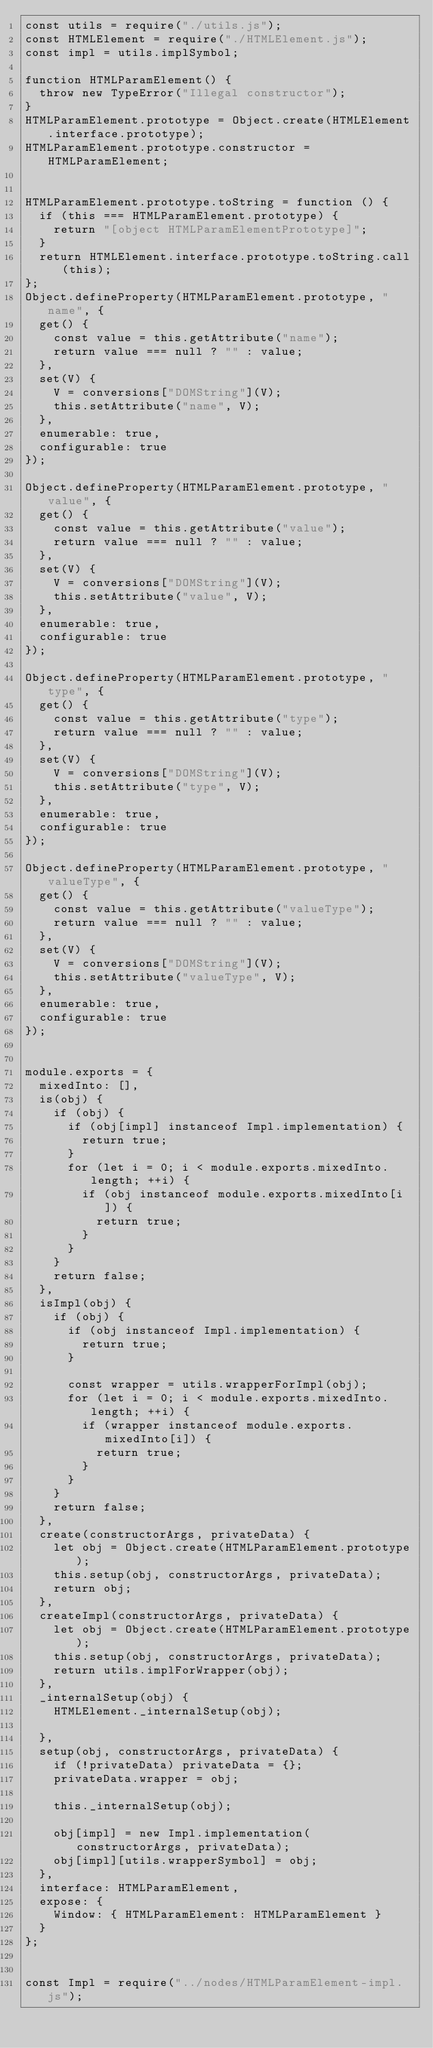Convert code to text. <code><loc_0><loc_0><loc_500><loc_500><_JavaScript_>const utils = require("./utils.js");
const HTMLElement = require("./HTMLElement.js");
const impl = utils.implSymbol;

function HTMLParamElement() {
  throw new TypeError("Illegal constructor");
}
HTMLParamElement.prototype = Object.create(HTMLElement.interface.prototype);
HTMLParamElement.prototype.constructor = HTMLParamElement;


HTMLParamElement.prototype.toString = function () {
  if (this === HTMLParamElement.prototype) {
    return "[object HTMLParamElementPrototype]";
  }
  return HTMLElement.interface.prototype.toString.call(this);
};
Object.defineProperty(HTMLParamElement.prototype, "name", {
  get() {
    const value = this.getAttribute("name");
    return value === null ? "" : value;
  },
  set(V) {
    V = conversions["DOMString"](V);
    this.setAttribute("name", V);
  },
  enumerable: true,
  configurable: true
});

Object.defineProperty(HTMLParamElement.prototype, "value", {
  get() {
    const value = this.getAttribute("value");
    return value === null ? "" : value;
  },
  set(V) {
    V = conversions["DOMString"](V);
    this.setAttribute("value", V);
  },
  enumerable: true,
  configurable: true
});

Object.defineProperty(HTMLParamElement.prototype, "type", {
  get() {
    const value = this.getAttribute("type");
    return value === null ? "" : value;
  },
  set(V) {
    V = conversions["DOMString"](V);
    this.setAttribute("type", V);
  },
  enumerable: true,
  configurable: true
});

Object.defineProperty(HTMLParamElement.prototype, "valueType", {
  get() {
    const value = this.getAttribute("valueType");
    return value === null ? "" : value;
  },
  set(V) {
    V = conversions["DOMString"](V);
    this.setAttribute("valueType", V);
  },
  enumerable: true,
  configurable: true
});


module.exports = {
  mixedInto: [],
  is(obj) {
    if (obj) {
      if (obj[impl] instanceof Impl.implementation) {
        return true;
      }
      for (let i = 0; i < module.exports.mixedInto.length; ++i) {
        if (obj instanceof module.exports.mixedInto[i]) {
          return true;
        }
      }
    }
    return false;
  },
  isImpl(obj) {
    if (obj) {
      if (obj instanceof Impl.implementation) {
        return true;
      }

      const wrapper = utils.wrapperForImpl(obj);
      for (let i = 0; i < module.exports.mixedInto.length; ++i) {
        if (wrapper instanceof module.exports.mixedInto[i]) {
          return true;
        }
      }
    }
    return false;
  },
  create(constructorArgs, privateData) {
    let obj = Object.create(HTMLParamElement.prototype);
    this.setup(obj, constructorArgs, privateData);
    return obj;
  },
  createImpl(constructorArgs, privateData) {
    let obj = Object.create(HTMLParamElement.prototype);
    this.setup(obj, constructorArgs, privateData);
    return utils.implForWrapper(obj);
  },
  _internalSetup(obj) {
    HTMLElement._internalSetup(obj);

  },
  setup(obj, constructorArgs, privateData) {
    if (!privateData) privateData = {};
    privateData.wrapper = obj;

    this._internalSetup(obj);

    obj[impl] = new Impl.implementation(constructorArgs, privateData);
    obj[impl][utils.wrapperSymbol] = obj;
  },
  interface: HTMLParamElement,
  expose: {
    Window: { HTMLParamElement: HTMLParamElement }
  }
};


const Impl = require("../nodes/HTMLParamElement-impl.js");
</code> 